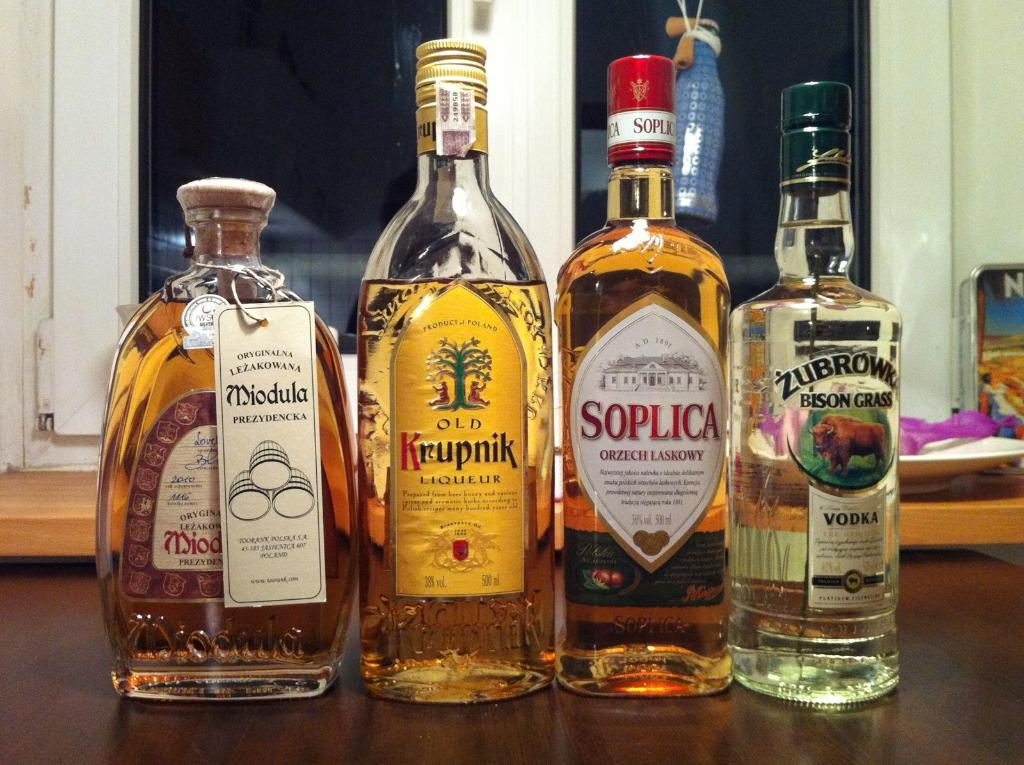<image>
Create a compact narrative representing the image presented. the word Soplica that is on a an alcohol bottle 